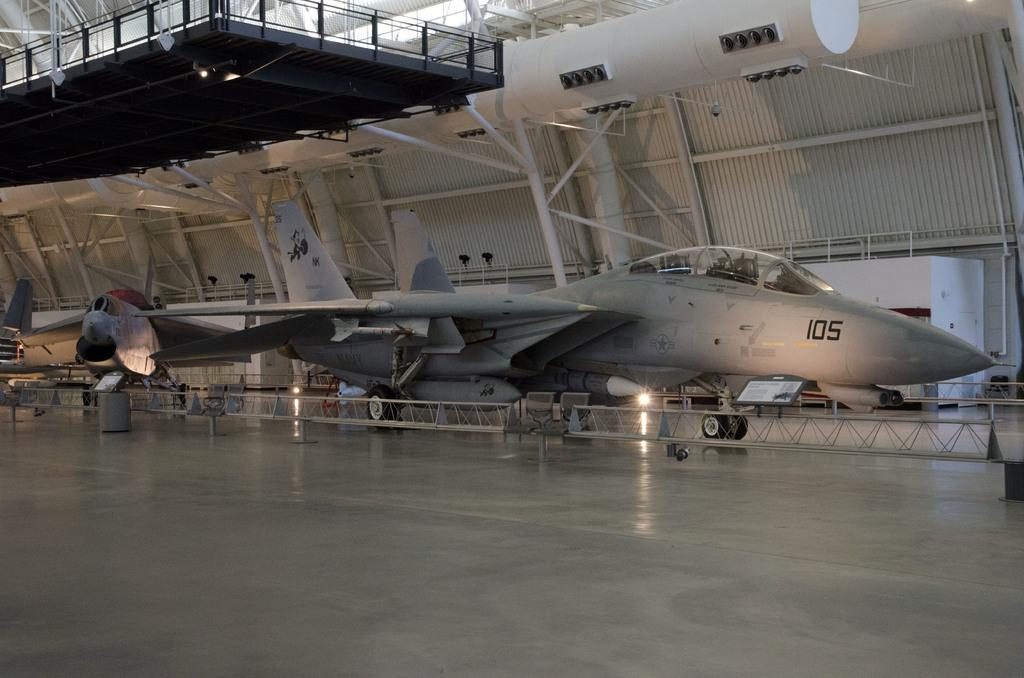<image>
Write a terse but informative summary of the picture. a plane with the number 105 on the side of it 